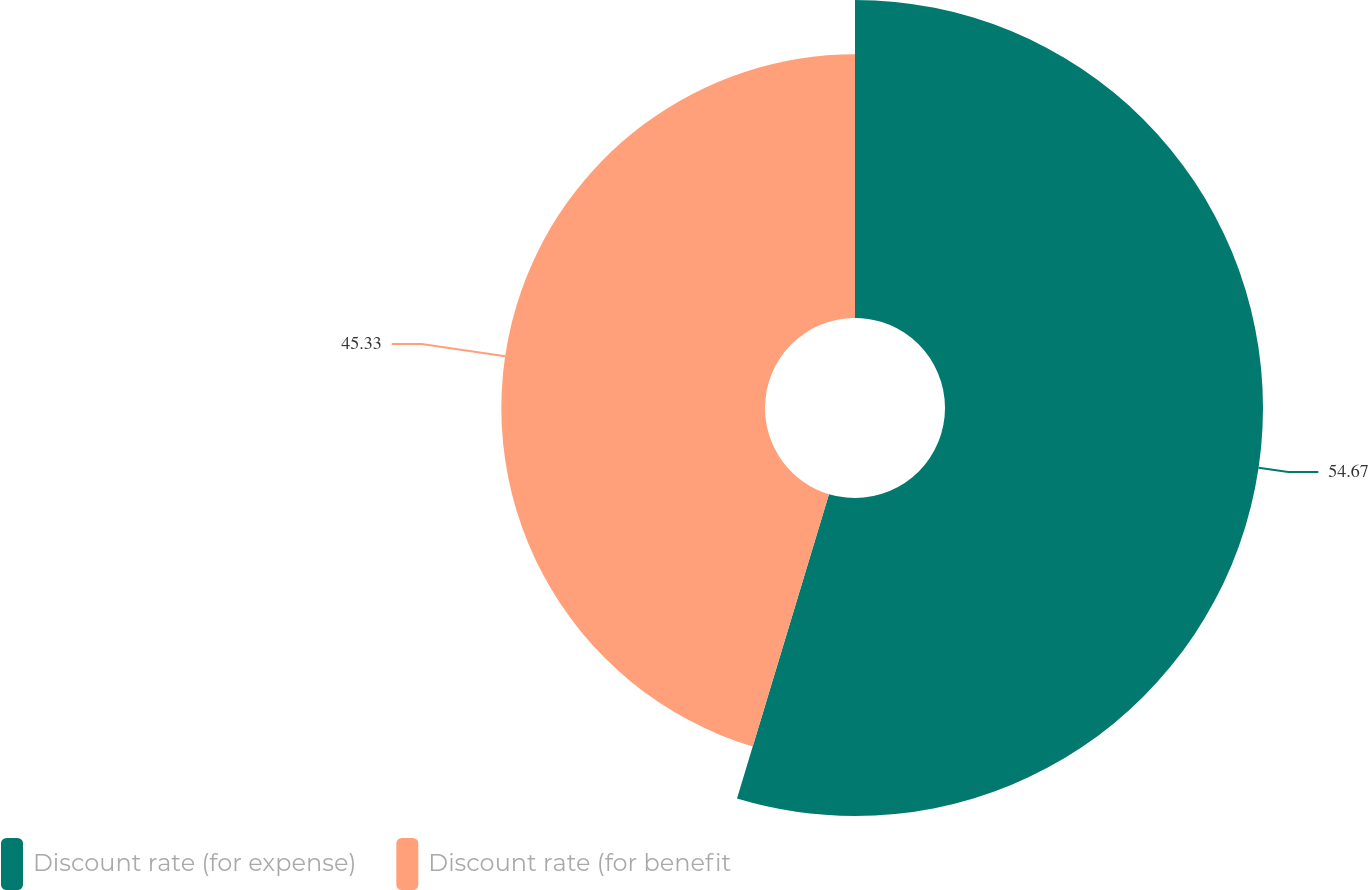Convert chart. <chart><loc_0><loc_0><loc_500><loc_500><pie_chart><fcel>Discount rate (for expense)<fcel>Discount rate (for benefit<nl><fcel>54.67%<fcel>45.33%<nl></chart> 